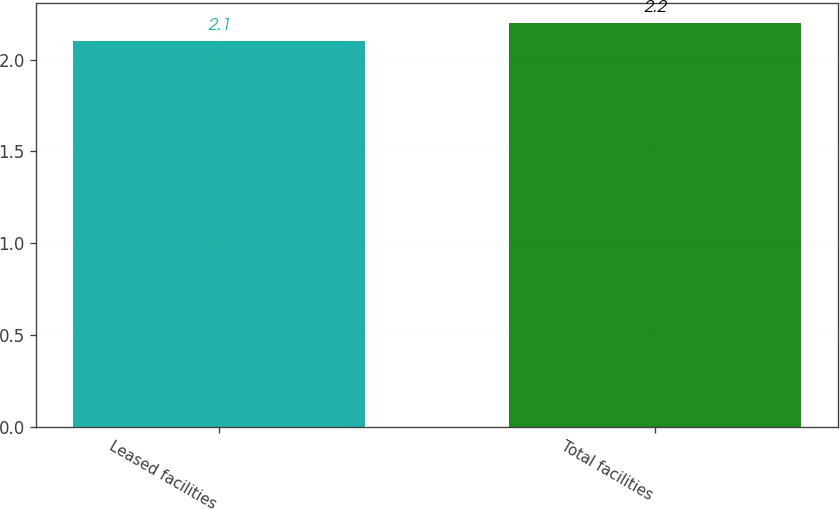<chart> <loc_0><loc_0><loc_500><loc_500><bar_chart><fcel>Leased facilities<fcel>Total facilities<nl><fcel>2.1<fcel>2.2<nl></chart> 